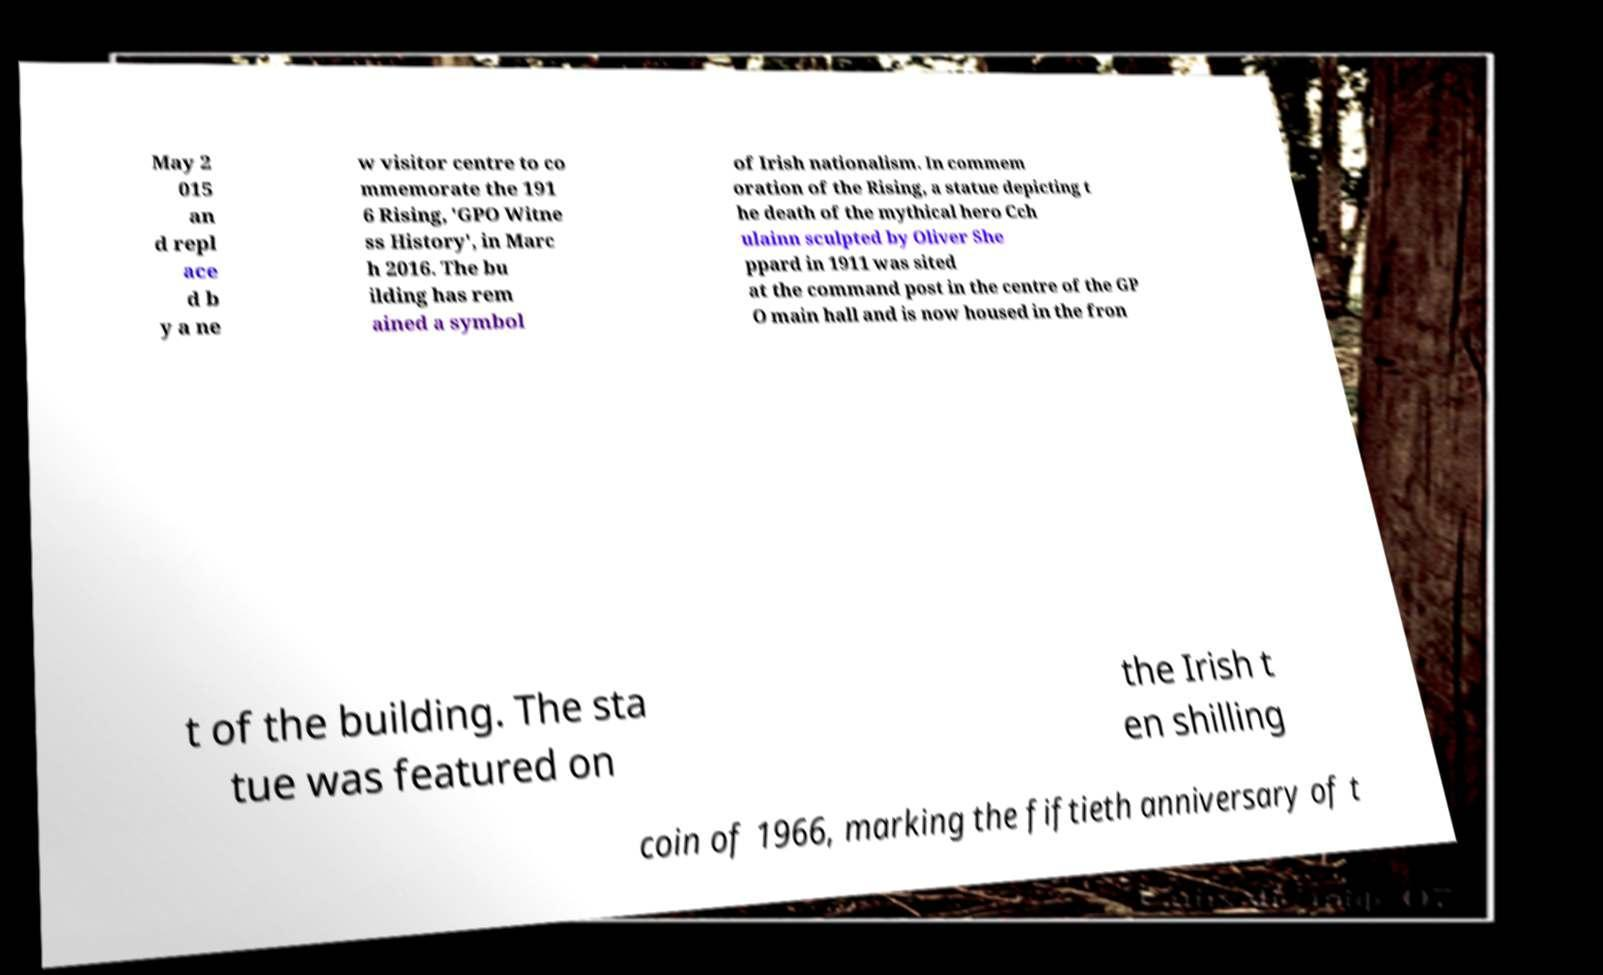Can you read and provide the text displayed in the image?This photo seems to have some interesting text. Can you extract and type it out for me? May 2 015 an d repl ace d b y a ne w visitor centre to co mmemorate the 191 6 Rising, 'GPO Witne ss History', in Marc h 2016. The bu ilding has rem ained a symbol of Irish nationalism. In commem oration of the Rising, a statue depicting t he death of the mythical hero Cch ulainn sculpted by Oliver She ppard in 1911 was sited at the command post in the centre of the GP O main hall and is now housed in the fron t of the building. The sta tue was featured on the Irish t en shilling coin of 1966, marking the fiftieth anniversary of t 